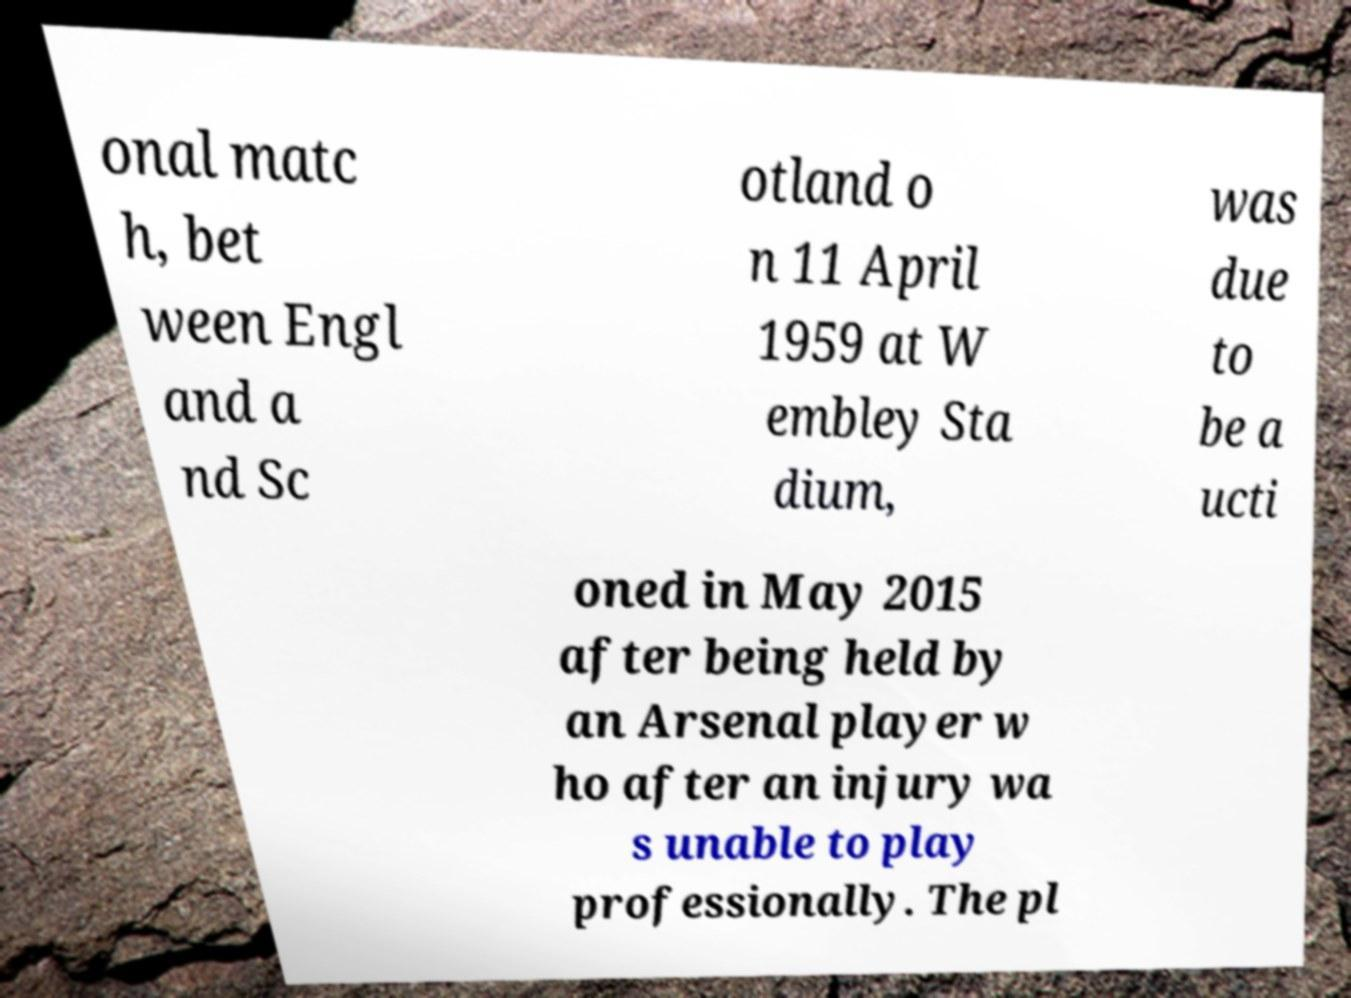There's text embedded in this image that I need extracted. Can you transcribe it verbatim? onal matc h, bet ween Engl and a nd Sc otland o n 11 April 1959 at W embley Sta dium, was due to be a ucti oned in May 2015 after being held by an Arsenal player w ho after an injury wa s unable to play professionally. The pl 